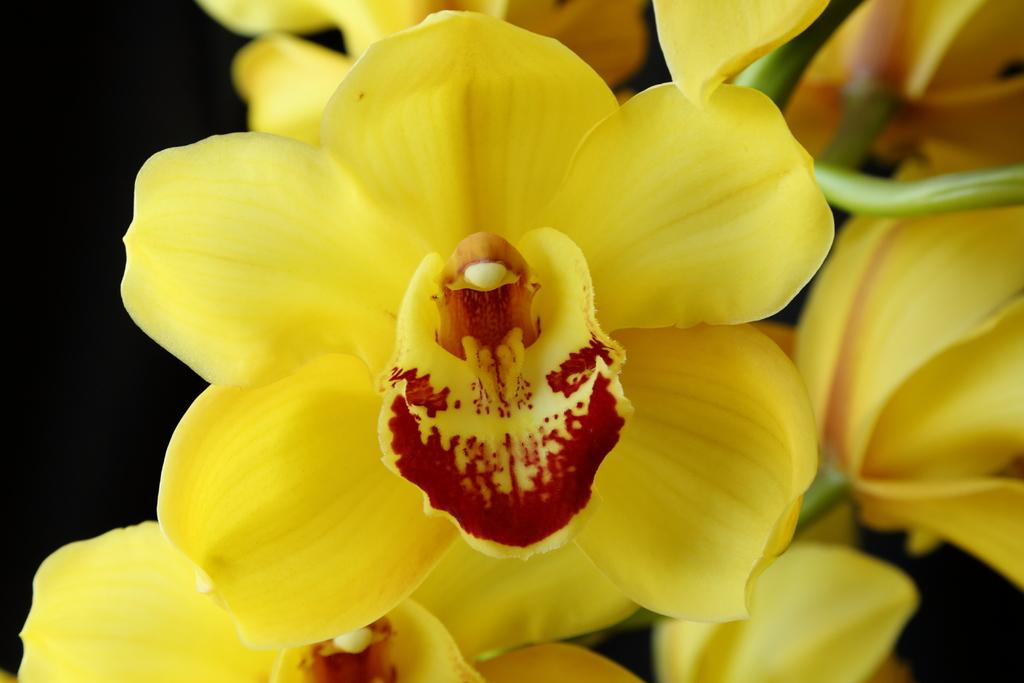What type of flowers can be seen in the image? There are yellow flowers in the image. How would you describe the overall color scheme of the image? The background of the image is dark. What type of nail is being used to hang the fog in the image? There is no nail or fog present in the image; it only features yellow flowers against a dark background. 